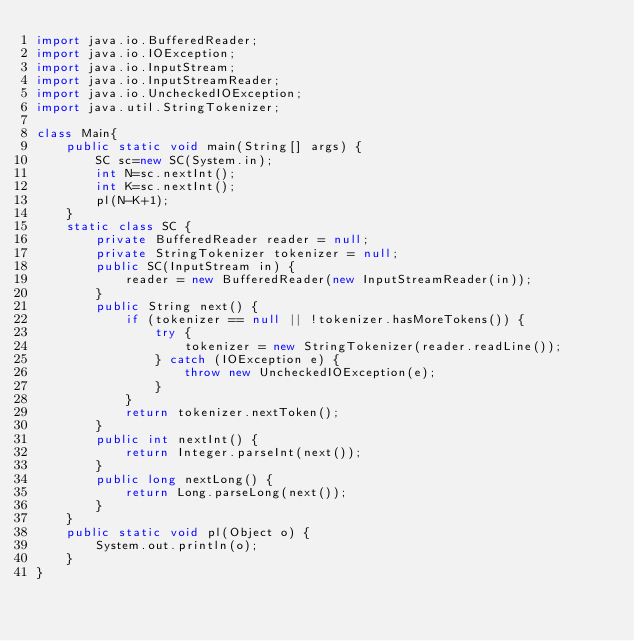Convert code to text. <code><loc_0><loc_0><loc_500><loc_500><_Java_>import java.io.BufferedReader;
import java.io.IOException;
import java.io.InputStream;
import java.io.InputStreamReader;
import java.io.UncheckedIOException;
import java.util.StringTokenizer;

class Main{
	public static void main(String[] args) {
		SC sc=new SC(System.in);
		int N=sc.nextInt();
		int K=sc.nextInt();
		pl(N-K+1);
	}
	static class SC {
		private BufferedReader reader = null;
		private StringTokenizer tokenizer = null;
		public SC(InputStream in) {
			reader = new BufferedReader(new InputStreamReader(in));
		}
		public String next() {
			if (tokenizer == null || !tokenizer.hasMoreTokens()) {
				try {
					tokenizer = new StringTokenizer(reader.readLine());
				} catch (IOException e) {
					throw new UncheckedIOException(e);
				}
			}
			return tokenizer.nextToken();
		}
		public int nextInt() {
			return Integer.parseInt(next());
		}
		public long nextLong() {
			return Long.parseLong(next());
		}
	}
	public static void pl(Object o) {
		System.out.println(o);
	}
}</code> 